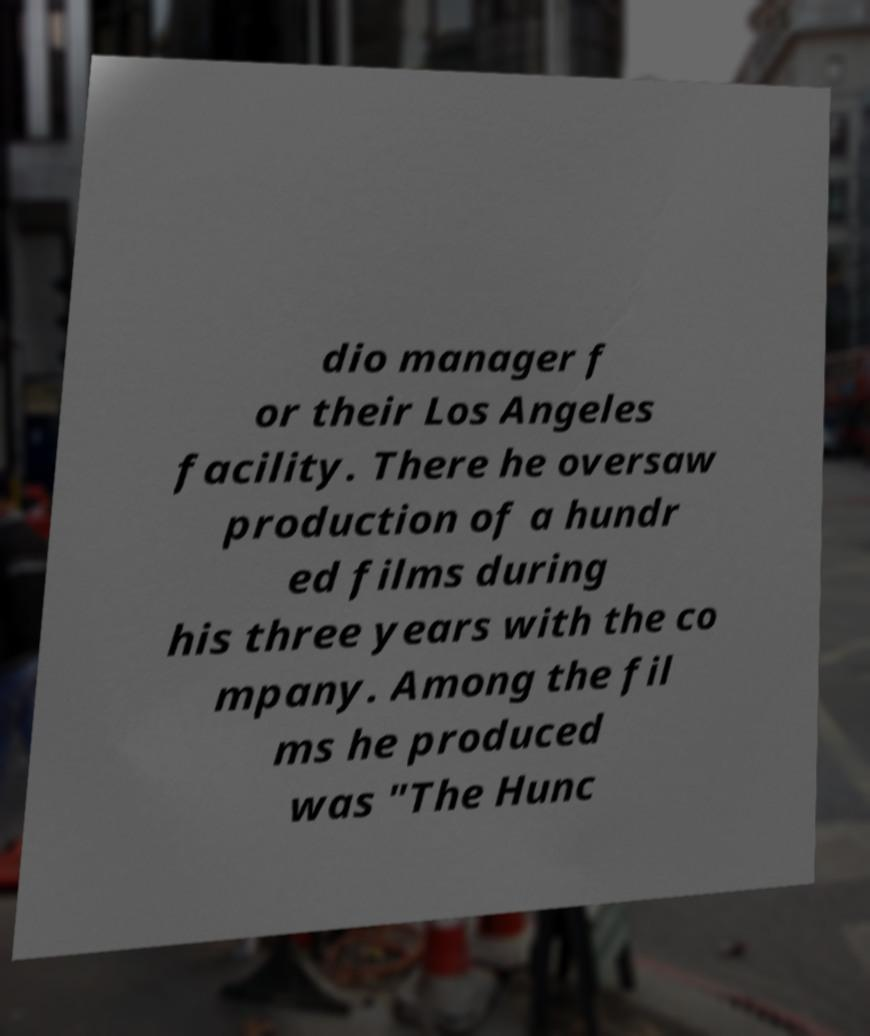Please read and relay the text visible in this image. What does it say? dio manager f or their Los Angeles facility. There he oversaw production of a hundr ed films during his three years with the co mpany. Among the fil ms he produced was "The Hunc 